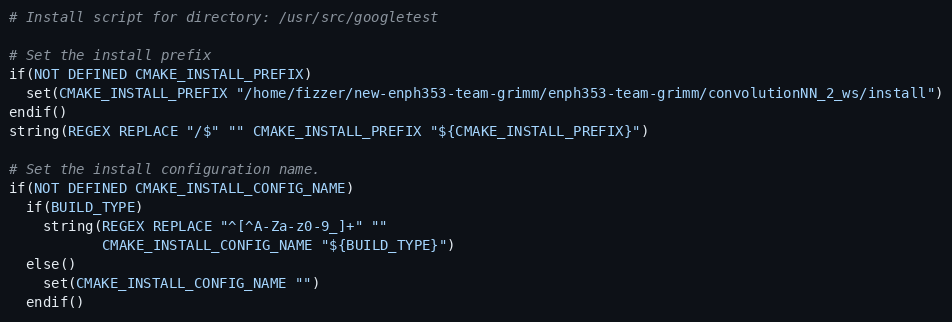Convert code to text. <code><loc_0><loc_0><loc_500><loc_500><_CMake_># Install script for directory: /usr/src/googletest

# Set the install prefix
if(NOT DEFINED CMAKE_INSTALL_PREFIX)
  set(CMAKE_INSTALL_PREFIX "/home/fizzer/new-enph353-team-grimm/enph353-team-grimm/convolutionNN_2_ws/install")
endif()
string(REGEX REPLACE "/$" "" CMAKE_INSTALL_PREFIX "${CMAKE_INSTALL_PREFIX}")

# Set the install configuration name.
if(NOT DEFINED CMAKE_INSTALL_CONFIG_NAME)
  if(BUILD_TYPE)
    string(REGEX REPLACE "^[^A-Za-z0-9_]+" ""
           CMAKE_INSTALL_CONFIG_NAME "${BUILD_TYPE}")
  else()
    set(CMAKE_INSTALL_CONFIG_NAME "")
  endif()</code> 